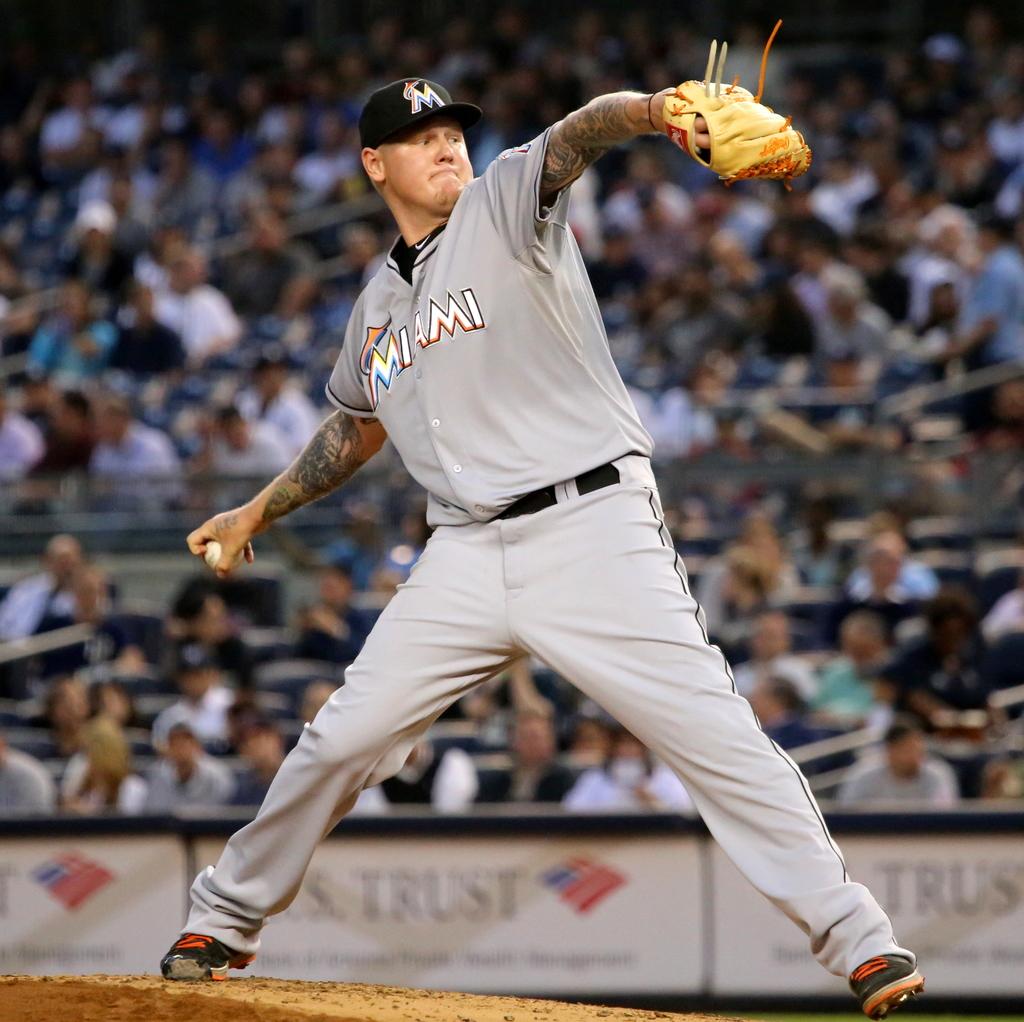What mlb team does the pitcher belong to?
Give a very brief answer. Miami. 